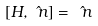Convert formula to latex. <formula><loc_0><loc_0><loc_500><loc_500>[ H , \hat { \ n } ] = \hat { \ n }</formula> 